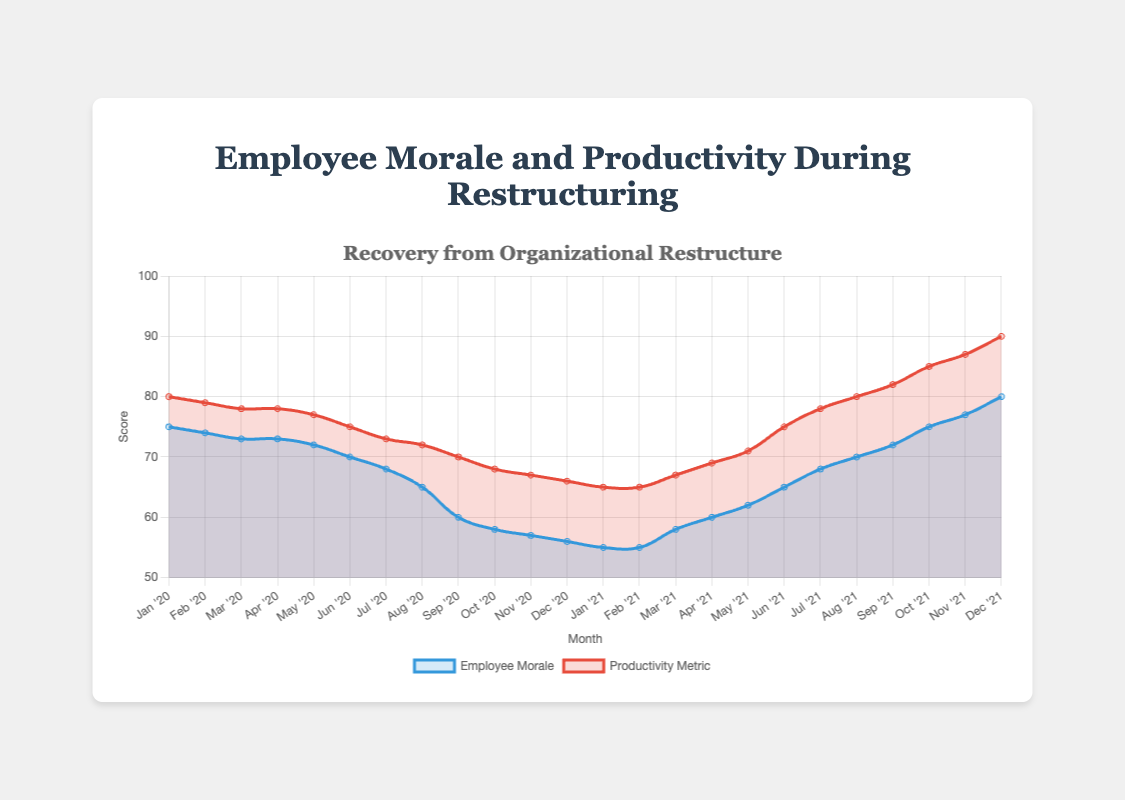What is the general trend in employee morale from January 2020 to December 2021? Employee morale initially decreases from January 2020, bottoming out in January 2021, then gradually improves until December 2021.
Answer: Initial decrease, then recovery Comparing June 2020 with June 2021, how do the employee morale and productivity metrics differ? In June 2020, employee morale is 70, and productivity is 75. In June 2021, employee morale is 65, and productivity is 75.
Answer: Morale significantly improved; productivity remained constant Which month shows the lowest employee morale, and what is the productivity metric at that time? The lowest employee morale is in January 2021, with a morale score of 55 and a productivity metric of 65.
Answer: January 2021; productivity is 65 During which months do the employee morale and productivity metrics show the highest increase in one month? From February 2021 to March 2021, employee morale increases by 3 points (55 to 58), and productivity rises by 2 points (65 to 67).
Answer: February to March 2021 What is the difference in productivity between the highest and lowest months? The highest productivity score is 90 (December 2021), and the lowest is 65 (January and February 2021). The difference is 25.
Answer: 25 Does employee morale recover to its initial value by the end of 2021? Employee morale starts at 75 in January 2020 and recovers to 80 by December 2021.
Answer: Yes During which months in 2020 did both employee morale and productivity metrics remain constant? Both metrics remain constant from March 2020 to April 2020, with morale at 73 and productivity at 78.
Answer: March to April 2020 What is the average employee morale for the year 2020? Sum the monthly morale for 2020: (75 + 74 + 73 + 73 + 72 + 70 + 68 + 65 + 60 + 58 + 57 + 56) = 801. Divide by the number of months: 801 / 12 = 66.75.
Answer: 66.75 By how much did productivity increase from its lowest point to its highest point? The lowest productivity is 65 (January and February 2021). The highest is 90 (December 2021). The increase is 25 points.
Answer: 25 What color represents the employee morale data line? The employee morale data line is represented by a blue color.
Answer: Blue 